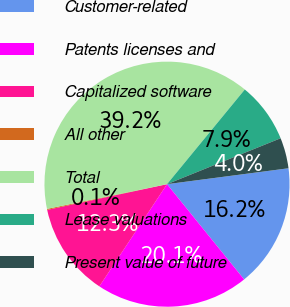<chart> <loc_0><loc_0><loc_500><loc_500><pie_chart><fcel>Customer-related<fcel>Patents licenses and<fcel>Capitalized software<fcel>All other<fcel>Total<fcel>Lease valuations<fcel>Present value of future<nl><fcel>16.24%<fcel>20.14%<fcel>12.33%<fcel>0.13%<fcel>39.18%<fcel>7.94%<fcel>4.04%<nl></chart> 